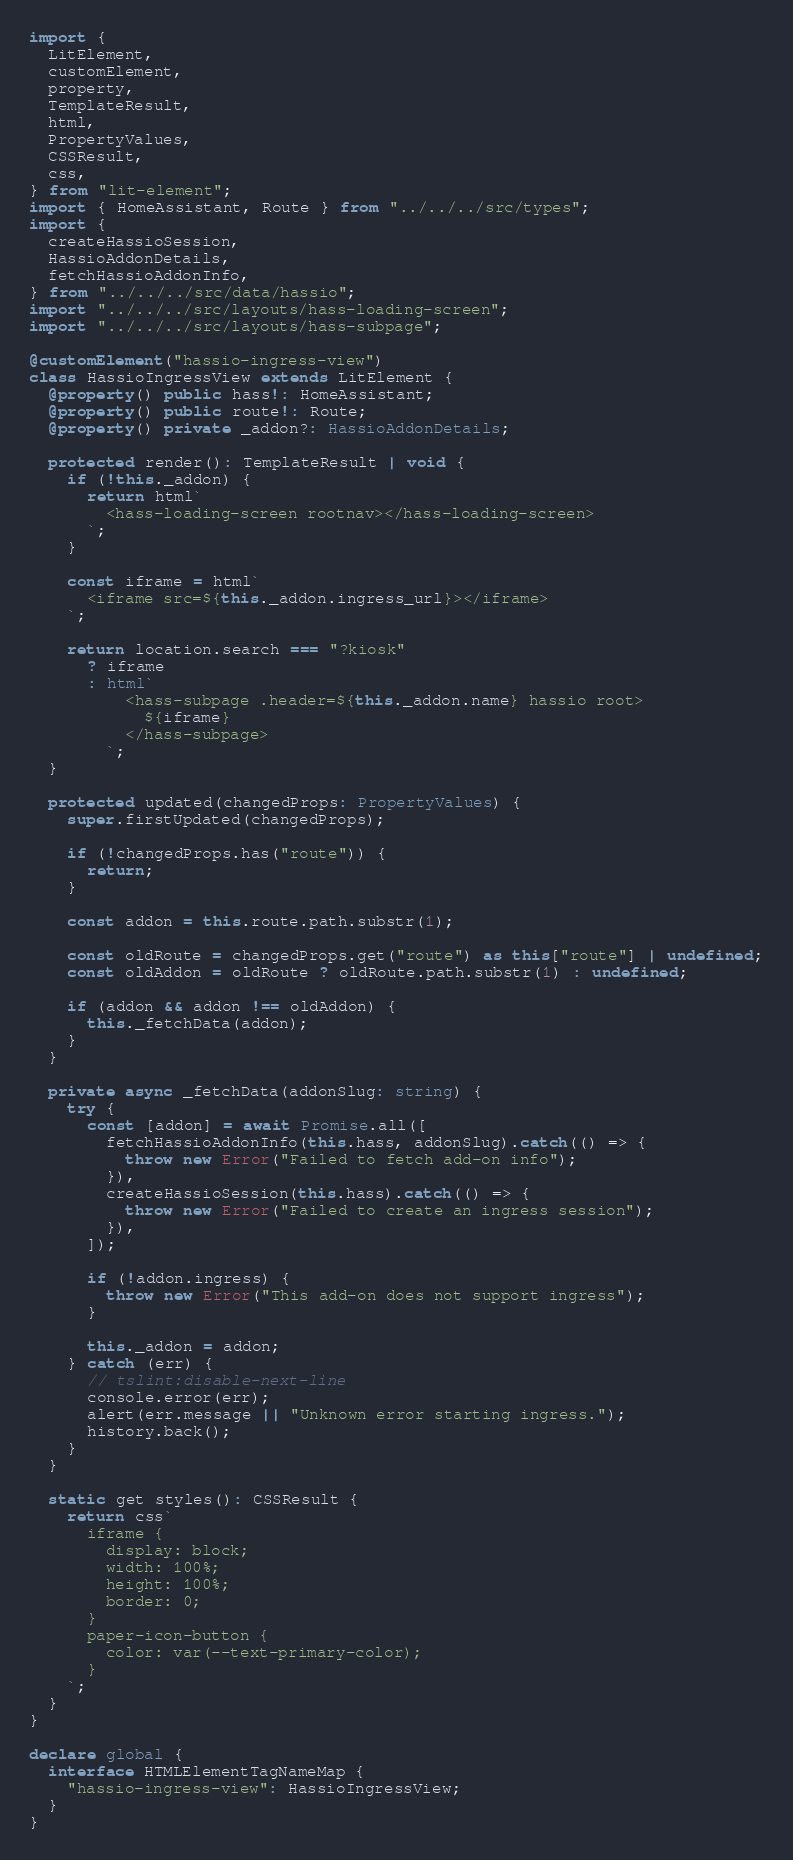Convert code to text. <code><loc_0><loc_0><loc_500><loc_500><_TypeScript_>import {
  LitElement,
  customElement,
  property,
  TemplateResult,
  html,
  PropertyValues,
  CSSResult,
  css,
} from "lit-element";
import { HomeAssistant, Route } from "../../../src/types";
import {
  createHassioSession,
  HassioAddonDetails,
  fetchHassioAddonInfo,
} from "../../../src/data/hassio";
import "../../../src/layouts/hass-loading-screen";
import "../../../src/layouts/hass-subpage";

@customElement("hassio-ingress-view")
class HassioIngressView extends LitElement {
  @property() public hass!: HomeAssistant;
  @property() public route!: Route;
  @property() private _addon?: HassioAddonDetails;

  protected render(): TemplateResult | void {
    if (!this._addon) {
      return html`
        <hass-loading-screen rootnav></hass-loading-screen>
      `;
    }

    const iframe = html`
      <iframe src=${this._addon.ingress_url}></iframe>
    `;

    return location.search === "?kiosk"
      ? iframe
      : html`
          <hass-subpage .header=${this._addon.name} hassio root>
            ${iframe}
          </hass-subpage>
        `;
  }

  protected updated(changedProps: PropertyValues) {
    super.firstUpdated(changedProps);

    if (!changedProps.has("route")) {
      return;
    }

    const addon = this.route.path.substr(1);

    const oldRoute = changedProps.get("route") as this["route"] | undefined;
    const oldAddon = oldRoute ? oldRoute.path.substr(1) : undefined;

    if (addon && addon !== oldAddon) {
      this._fetchData(addon);
    }
  }

  private async _fetchData(addonSlug: string) {
    try {
      const [addon] = await Promise.all([
        fetchHassioAddonInfo(this.hass, addonSlug).catch(() => {
          throw new Error("Failed to fetch add-on info");
        }),
        createHassioSession(this.hass).catch(() => {
          throw new Error("Failed to create an ingress session");
        }),
      ]);

      if (!addon.ingress) {
        throw new Error("This add-on does not support ingress");
      }

      this._addon = addon;
    } catch (err) {
      // tslint:disable-next-line
      console.error(err);
      alert(err.message || "Unknown error starting ingress.");
      history.back();
    }
  }

  static get styles(): CSSResult {
    return css`
      iframe {
        display: block;
        width: 100%;
        height: 100%;
        border: 0;
      }
      paper-icon-button {
        color: var(--text-primary-color);
      }
    `;
  }
}

declare global {
  interface HTMLElementTagNameMap {
    "hassio-ingress-view": HassioIngressView;
  }
}
</code> 